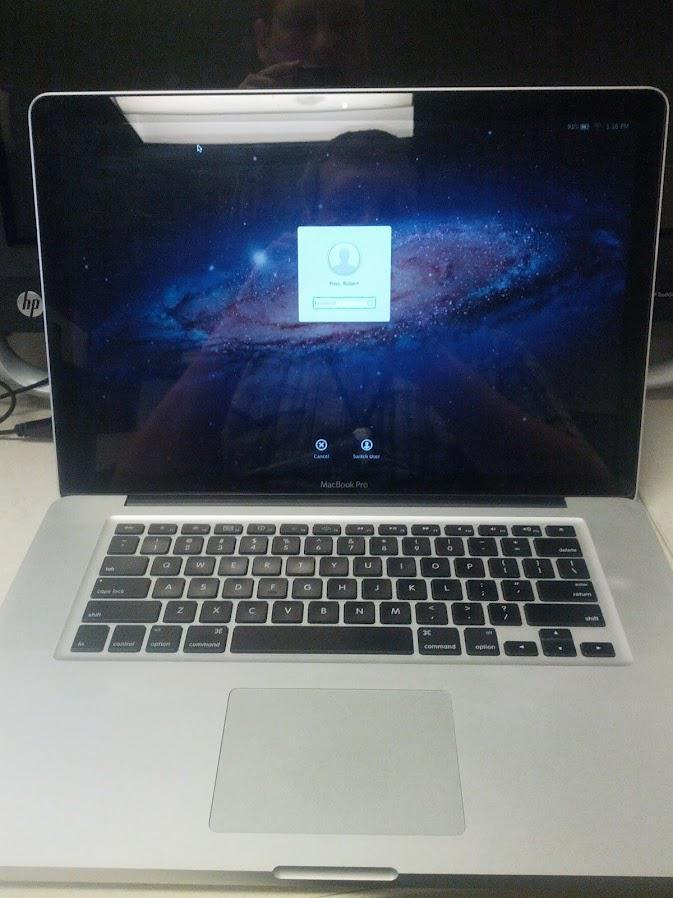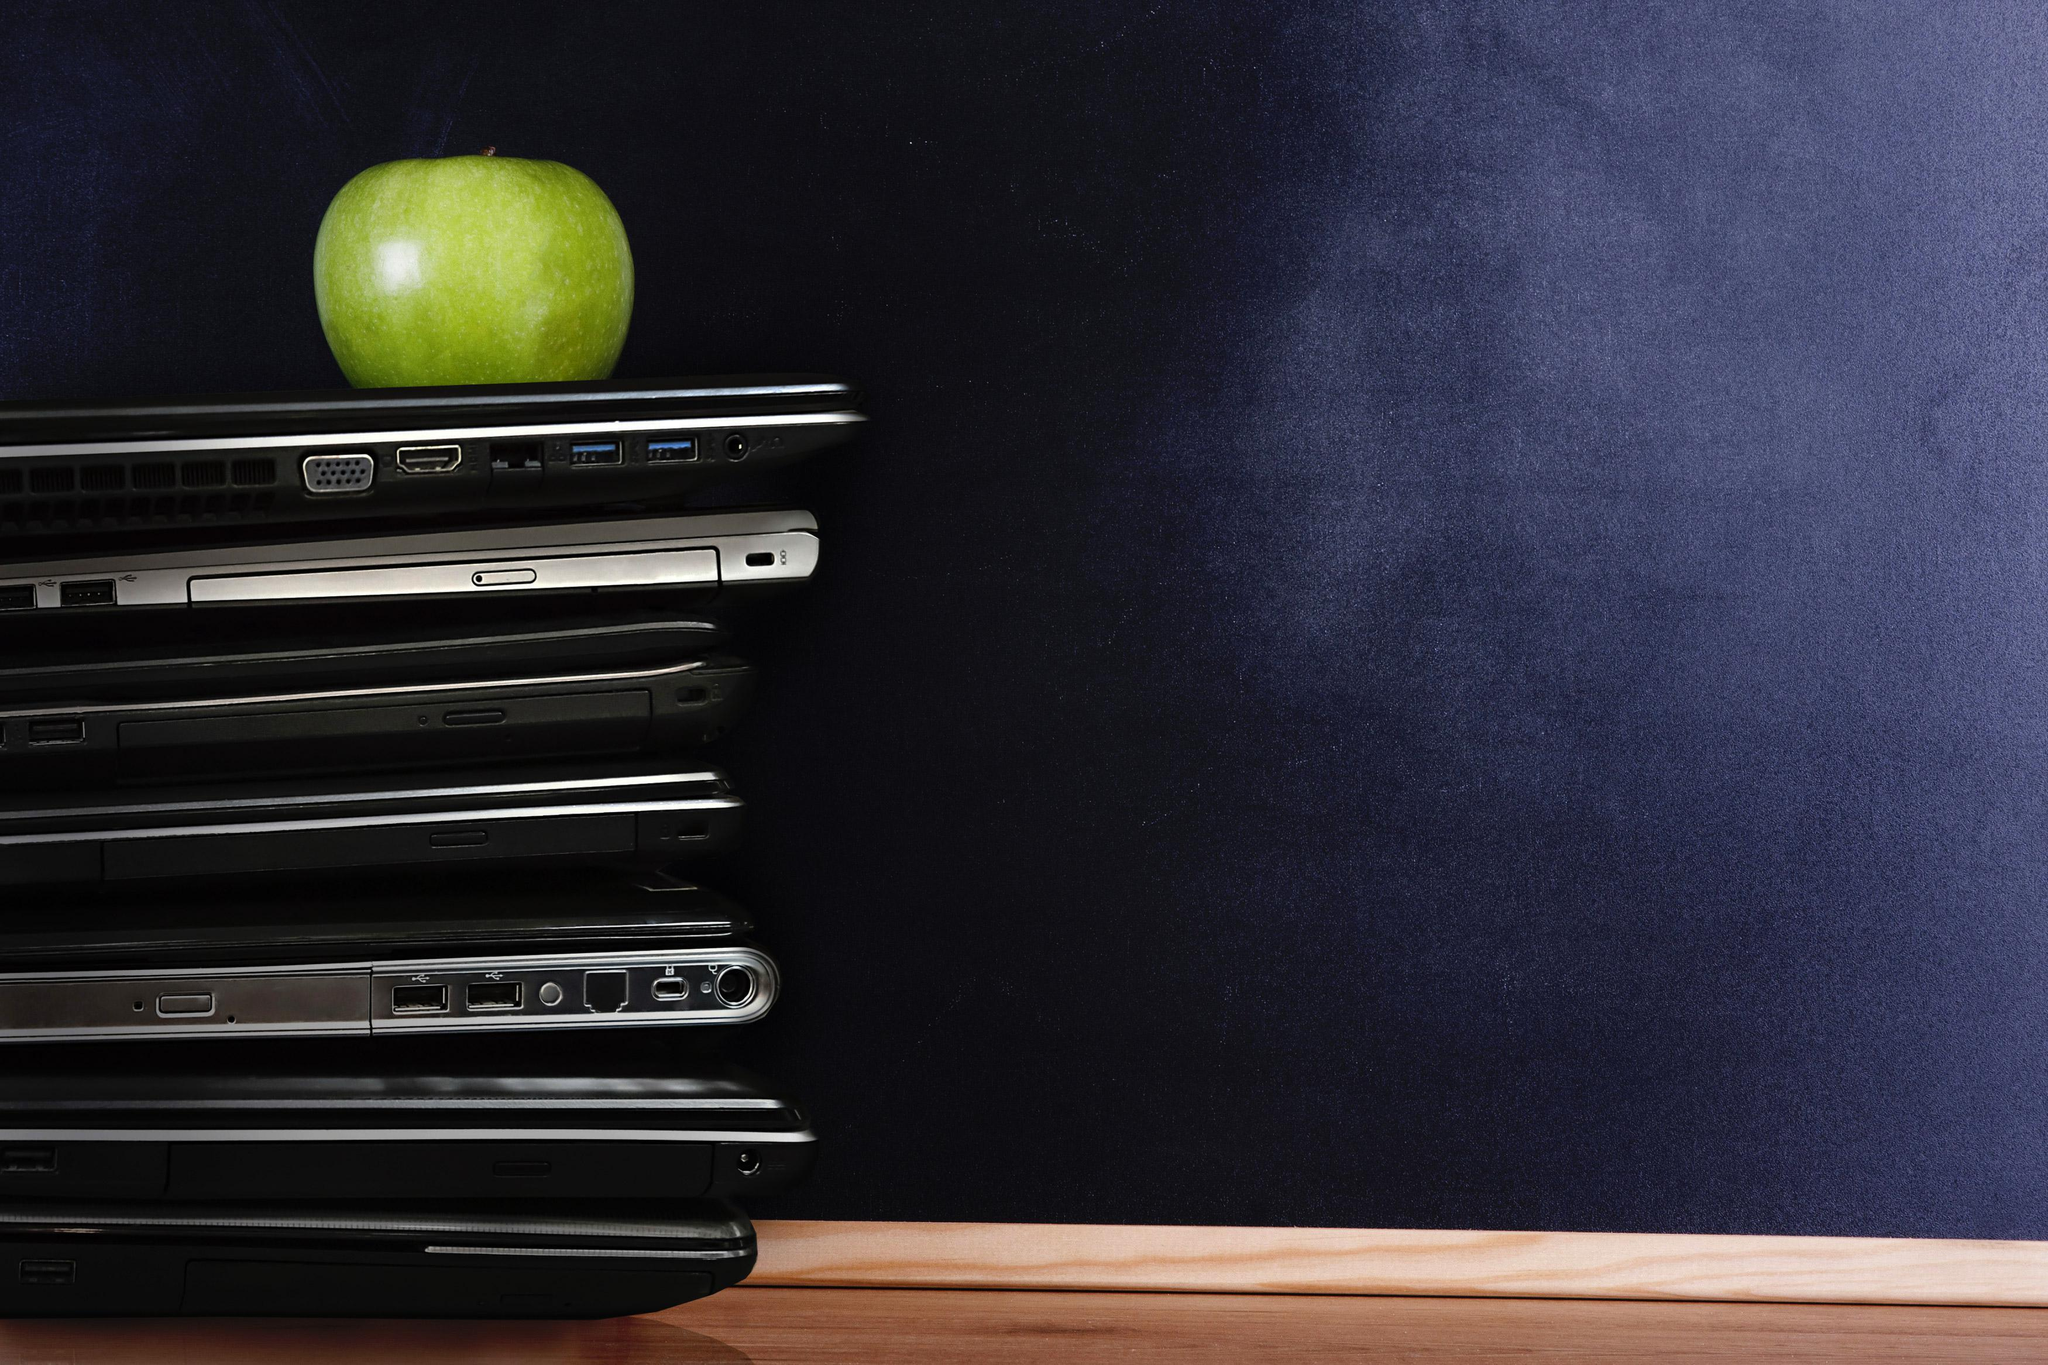The first image is the image on the left, the second image is the image on the right. Considering the images on both sides, is "In one image at least one laptop is open." valid? Answer yes or no. Yes. The first image is the image on the left, the second image is the image on the right. Evaluate the accuracy of this statement regarding the images: "There is at least one laptop open with the keyboard showing.". Is it true? Answer yes or no. Yes. 